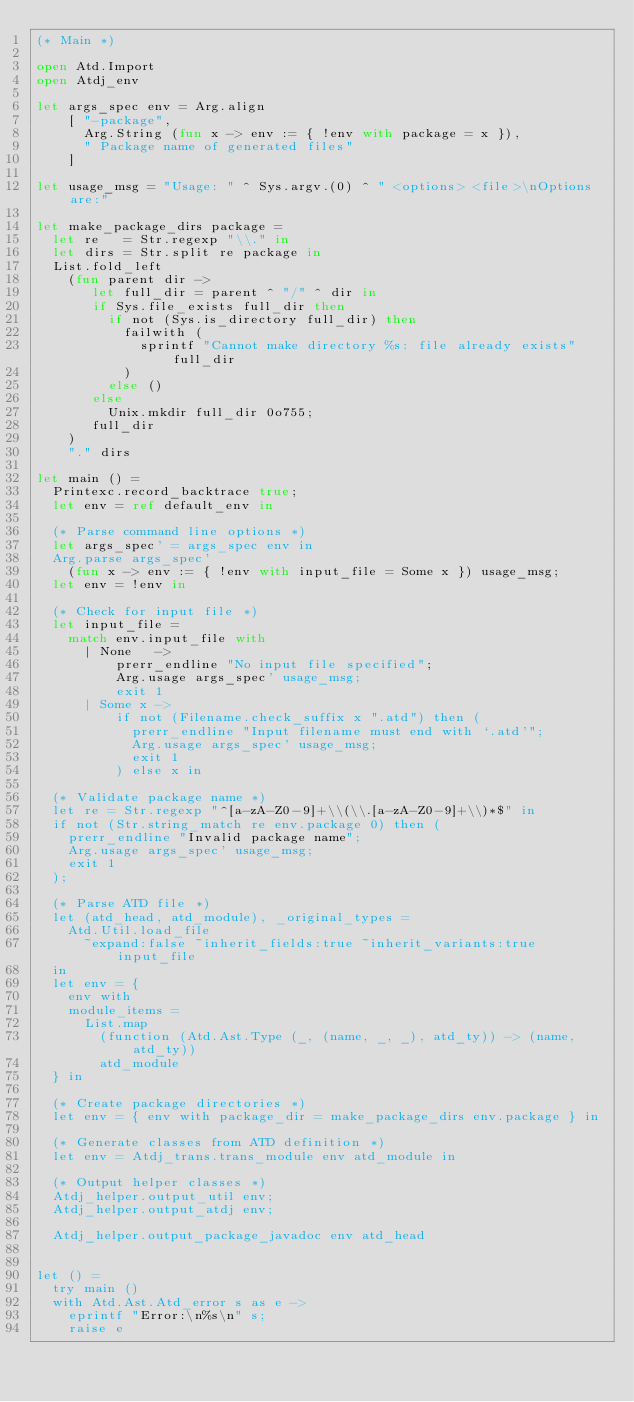<code> <loc_0><loc_0><loc_500><loc_500><_OCaml_>(* Main *)

open Atd.Import
open Atdj_env

let args_spec env = Arg.align
    [ "-package",
      Arg.String (fun x -> env := { !env with package = x }),
      " Package name of generated files"
    ]

let usage_msg = "Usage: " ^ Sys.argv.(0) ^ " <options> <file>\nOptions are:"

let make_package_dirs package =
  let re   = Str.regexp "\\." in
  let dirs = Str.split re package in
  List.fold_left
    (fun parent dir ->
       let full_dir = parent ^ "/" ^ dir in
       if Sys.file_exists full_dir then
         if not (Sys.is_directory full_dir) then
           failwith (
             sprintf "Cannot make directory %s: file already exists" full_dir
           )
         else ()
       else
         Unix.mkdir full_dir 0o755;
       full_dir
    )
    "." dirs

let main () =
  Printexc.record_backtrace true;
  let env = ref default_env in

  (* Parse command line options *)
  let args_spec' = args_spec env in
  Arg.parse args_spec'
    (fun x -> env := { !env with input_file = Some x }) usage_msg;
  let env = !env in

  (* Check for input file *)
  let input_file =
    match env.input_file with
      | None   ->
          prerr_endline "No input file specified";
          Arg.usage args_spec' usage_msg;
          exit 1
      | Some x ->
          if not (Filename.check_suffix x ".atd") then (
            prerr_endline "Input filename must end with `.atd'";
            Arg.usage args_spec' usage_msg;
            exit 1
          ) else x in

  (* Validate package name *)
  let re = Str.regexp "^[a-zA-Z0-9]+\\(\\.[a-zA-Z0-9]+\\)*$" in
  if not (Str.string_match re env.package 0) then (
    prerr_endline "Invalid package name";
    Arg.usage args_spec' usage_msg;
    exit 1
  );

  (* Parse ATD file *)
  let (atd_head, atd_module), _original_types =
    Atd.Util.load_file
      ~expand:false ~inherit_fields:true ~inherit_variants:true input_file
  in
  let env = {
    env with
    module_items =
      List.map
        (function (Atd.Ast.Type (_, (name, _, _), atd_ty)) -> (name, atd_ty))
        atd_module
  } in

  (* Create package directories *)
  let env = { env with package_dir = make_package_dirs env.package } in

  (* Generate classes from ATD definition *)
  let env = Atdj_trans.trans_module env atd_module in

  (* Output helper classes *)
  Atdj_helper.output_util env;
  Atdj_helper.output_atdj env;

  Atdj_helper.output_package_javadoc env atd_head


let () =
  try main ()
  with Atd.Ast.Atd_error s as e ->
    eprintf "Error:\n%s\n" s;
    raise e
</code> 